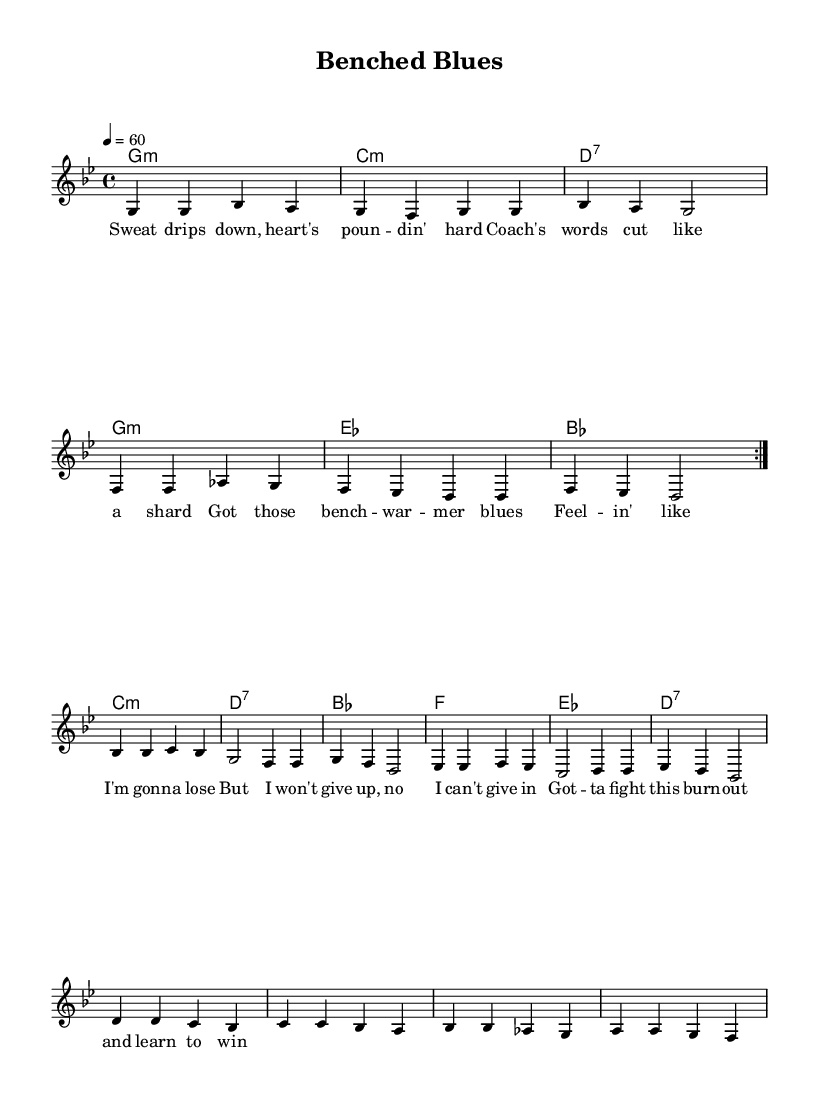What is the key signature of this music? The key signature is indicated as one flat (B♭), which is typical for G minor. It dictates the pitches to be used throughout the piece.
Answer: G minor What is the time signature of this music? The time signature is notated at the beginning as 4/4, meaning there are four beats in each measure with a quarter note receiving one beat.
Answer: 4/4 What is the tempo marking in this music? The tempo marking is located in the header, stating "4 = 60," which means the quarter note is set to 60 beats per minute.
Answer: 60 How many measures are in the music? By counting the measures in the melody section, there are a total of 16 measures present in the composition.
Answer: 16 What is the primary theme expressed in the lyrics? The lyrics focus on feelings of stress and burnout associated with sports, using imagery of physical exertion and mental struggle.
Answer: Stress and burnout What is the chord progression for the first section? The chord progression can be identified by analyzing the provided harmonies for the first part, which is G minor, C minor, D7, and G minor repeated.
Answer: G minor, C minor, D7, G minor What unique characteristic identifies this composition as a Blues ballad? The use of a twelve-bar structure with a melancholic theme and the expression of personal struggle is characteristic of Blues, making this composition fit within the genre.
Answer: Melancholic theme and personal struggle 